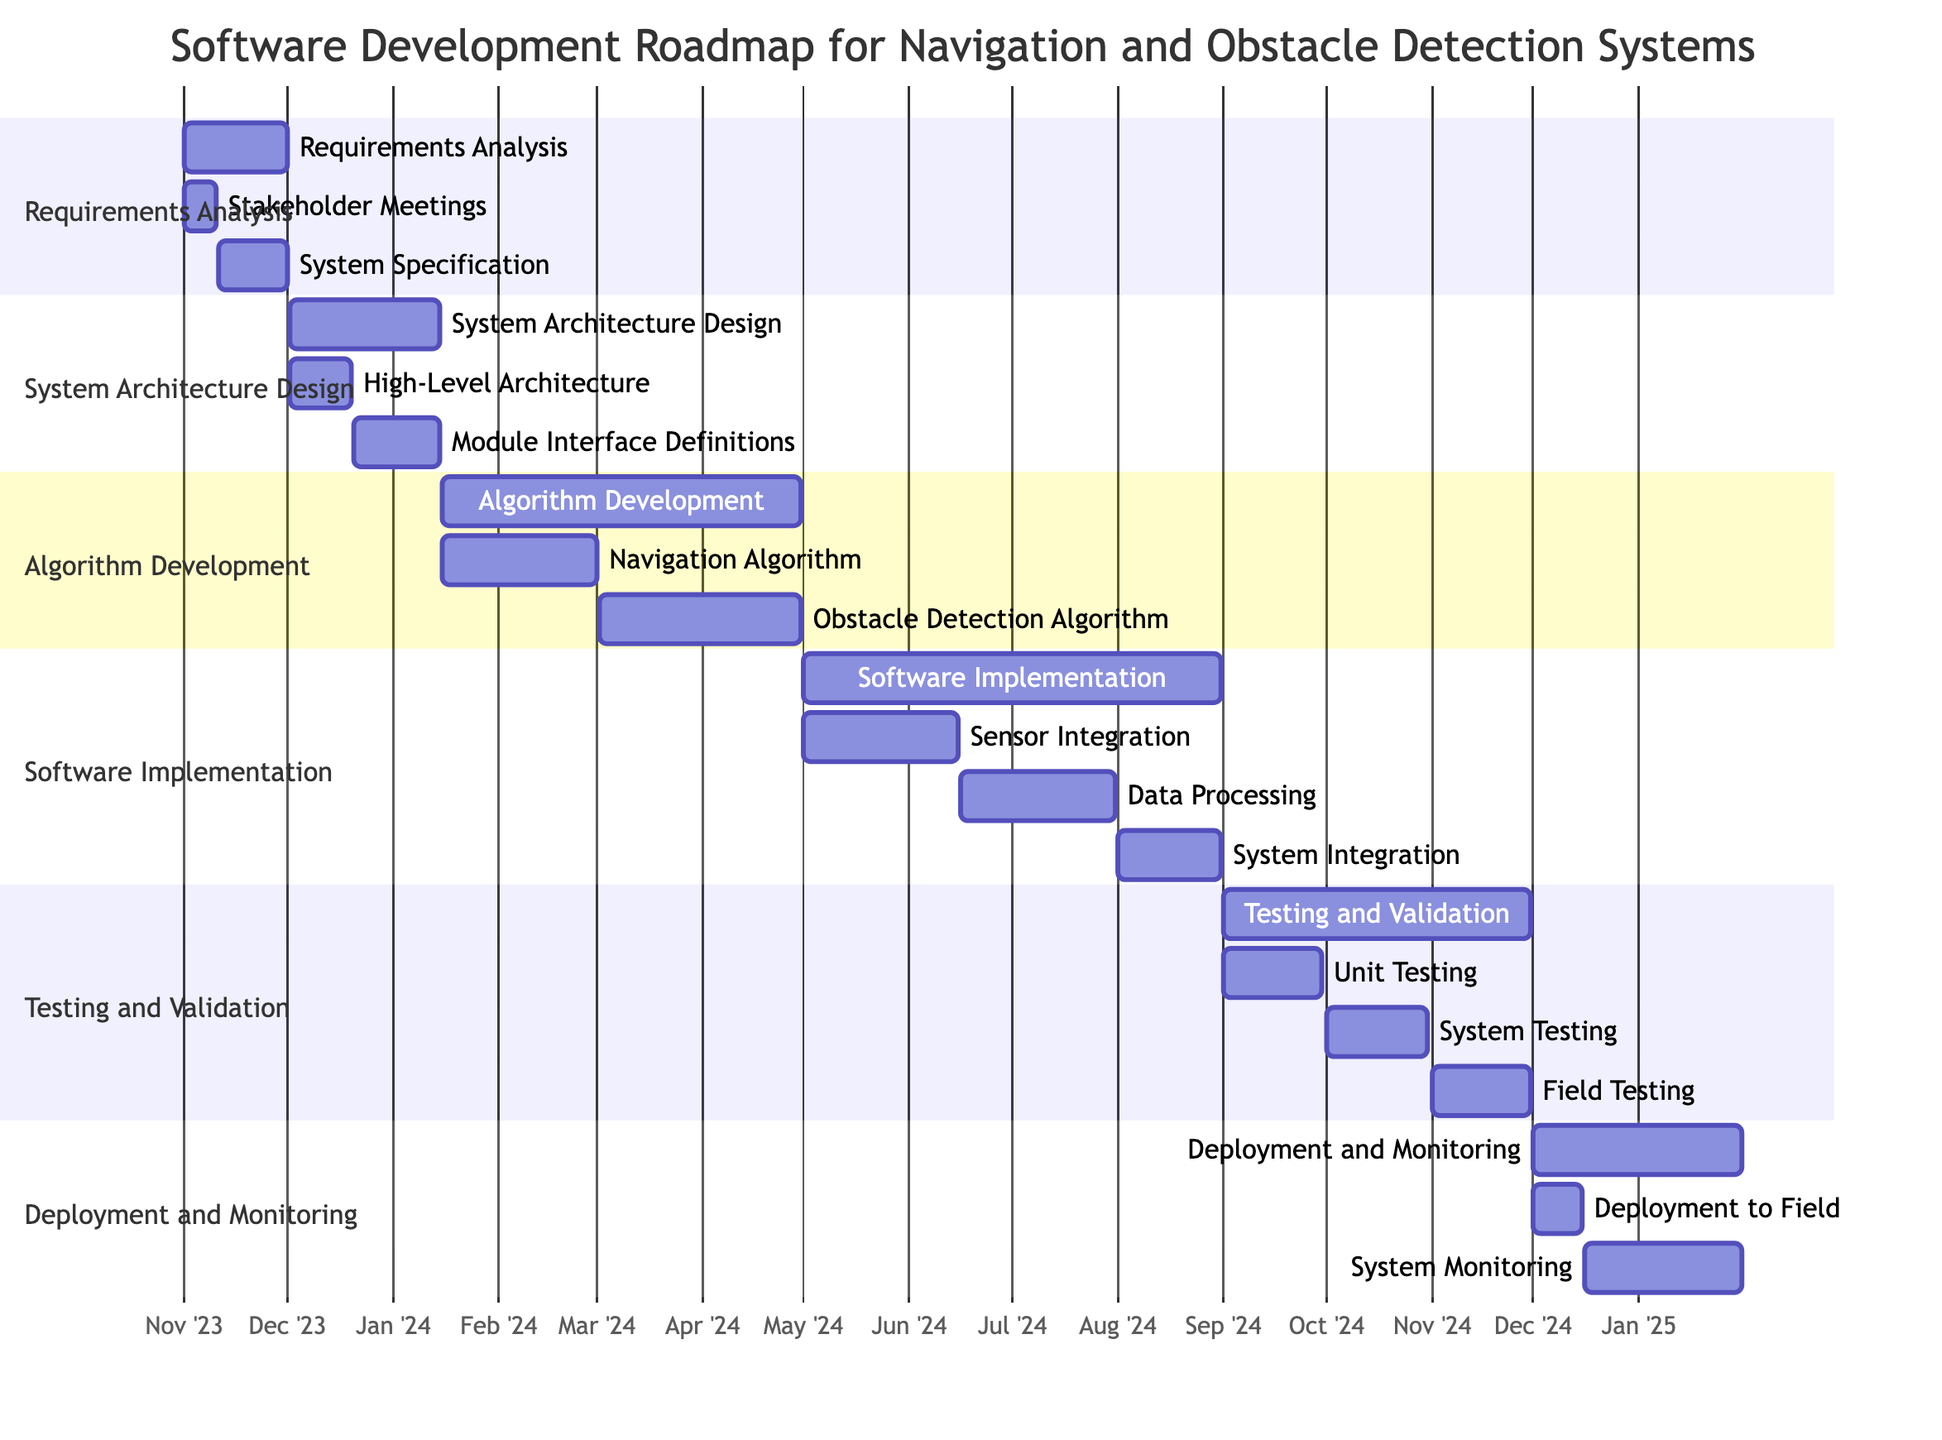What is the duration of the Requirements Analysis phase? The Requirements Analysis phase starts on November 1, 2023, and ends on December 1, 2023. Calculating the duration, this gives us a total of 30 days.
Answer: 30 days Which task follows System Specification Documentation? In the Gantt chart, the System Specification Documentation task ends on December 1, 2023, and is followed by the System Architecture Design phase, which starts on December 2, 2023.
Answer: System Architecture Design How many main phases are there in the roadmap? The roadmap consists of five main phases listed in the Gantt chart: Requirements Analysis, System Architecture Design, Algorithm Development, Software Implementation, and Testing and Validation, plus Deployment and Monitoring. Counting these gives a total of six main phases.
Answer: 6 What is the end date of the Field Testing subtask? The Field Testing subtask starts on November 1, 2024, and ends on November 30, 2024, as indicated in the Gantt chart. Therefore, the end date is November 30, 2024.
Answer: November 30, 2024 Which subtask occurs last in the Software Implementation section? In the Software Implementation section, the last subtask listed is System Integration, which runs from August 1, 2024, to August 31, 2024. Thus, System Integration is the last subtask in that phase.
Answer: System Integration What is the total duration of the Algorithm Development phase? The Algorithm Development phase starts on January 16, 2024, and ends on April 30, 2024. Calculating the duration from start to end gives a total of 105 days (from January 16 to April 30).
Answer: 105 days Which task overlaps with the Sensor Integration task? Sensor Integration runs from May 1, 2024, to June 15, 2024. The Data Processing task starts on June 16, 2024, meaning there is no overlap with Data Processing. The next task in Testing and Validation starts on September 1, 2024, which also has no overlap. However, the Navigation Algorithm overlaps with the early part of the Algorithm Development phase. Overlapping tasks must include those within the Algorithm Development phase, and the Navigation Algorithm specifically runs from January 16, 2024, to March 1, 2024, ending before the implementation phase begins.
Answer: None When do the algorithms start development? The Algorithm Development phase begins on January 16, 2024, as stated in the Gantt chart. Therefore, the algorithms start development on this date.
Answer: January 16, 2024 